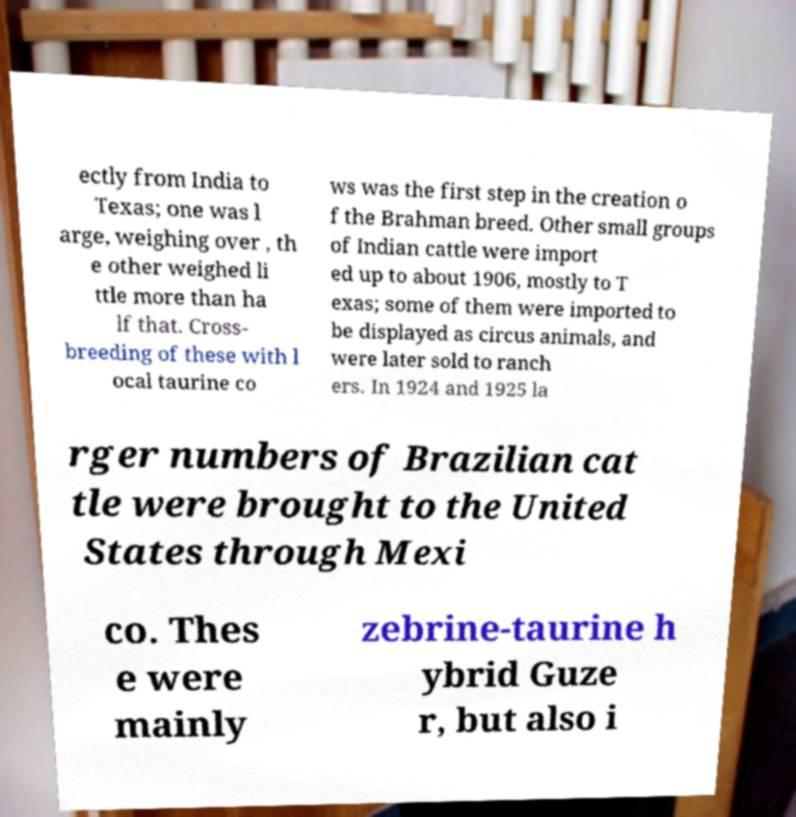Could you assist in decoding the text presented in this image and type it out clearly? ectly from India to Texas; one was l arge, weighing over , th e other weighed li ttle more than ha lf that. Cross- breeding of these with l ocal taurine co ws was the first step in the creation o f the Brahman breed. Other small groups of Indian cattle were import ed up to about 1906, mostly to T exas; some of them were imported to be displayed as circus animals, and were later sold to ranch ers. In 1924 and 1925 la rger numbers of Brazilian cat tle were brought to the United States through Mexi co. Thes e were mainly zebrine-taurine h ybrid Guze r, but also i 